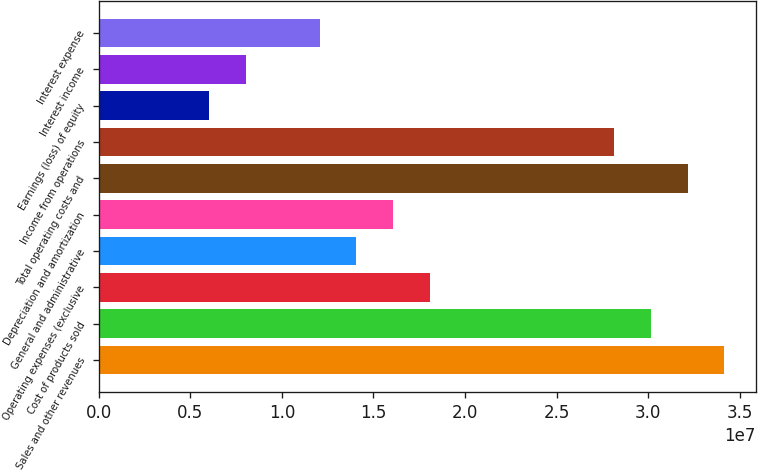Convert chart to OTSL. <chart><loc_0><loc_0><loc_500><loc_500><bar_chart><fcel>Sales and other revenues<fcel>Cost of products sold<fcel>Operating expenses (exclusive<fcel>General and administrative<fcel>Depreciation and amortization<fcel>Total operating costs and<fcel>Income from operations<fcel>Earnings (loss) of equity<fcel>Interest income<fcel>Interest expense<nl><fcel>3.41542e+07<fcel>3.01361e+07<fcel>1.80817e+07<fcel>1.40635e+07<fcel>1.60726e+07<fcel>3.21452e+07<fcel>2.8127e+07<fcel>6.02722e+06<fcel>8.03629e+06<fcel>1.20544e+07<nl></chart> 